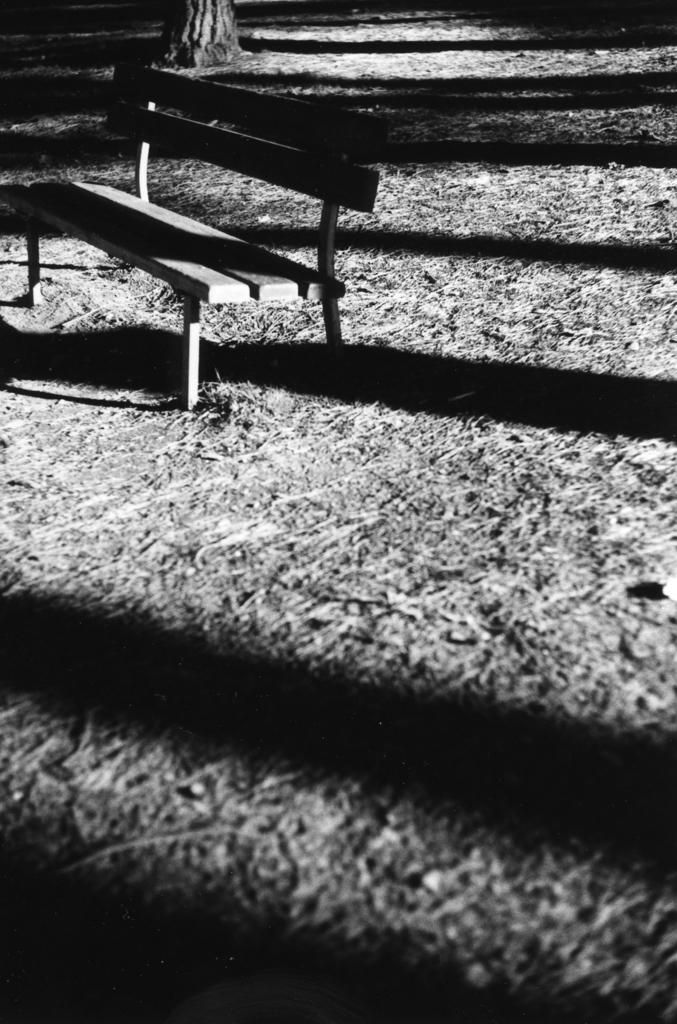What is the color scheme of the image? The image is black and white. What is located in the center of the image? There is a bench in the center of the image. What can be seen at the top of the image? There is a tree at the top of the image. What is visible in the background of the image? The ground is visible in the background of the image. How many cacti are visible in the image? There are no cacti present in the image. What type of degree does the tree have in the image? Trees do not have degrees; the question is not applicable to the image. 